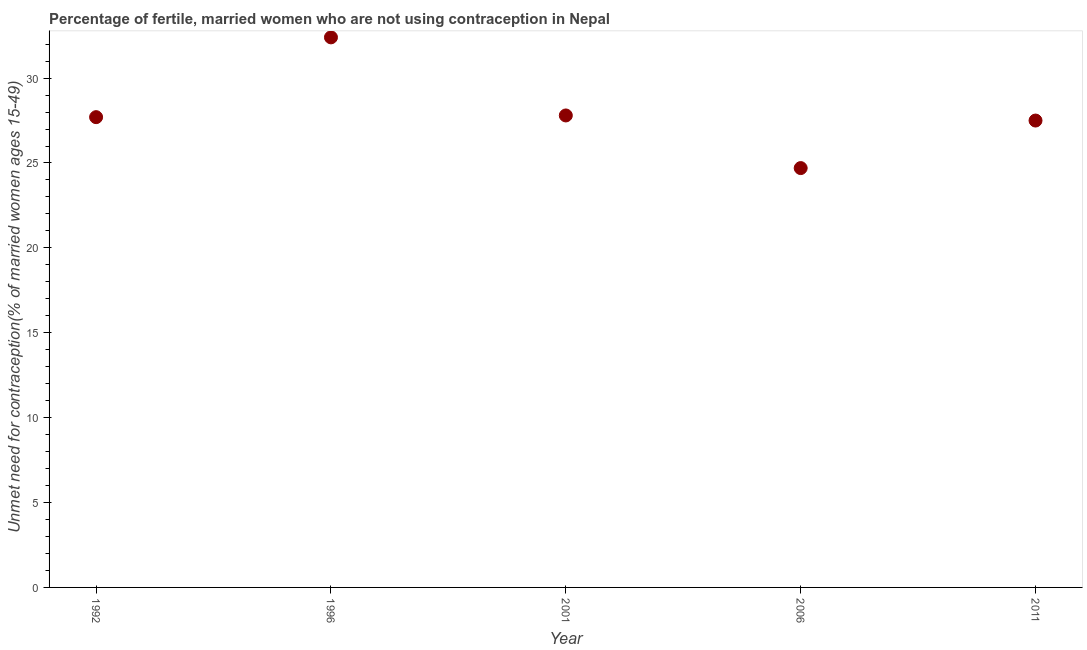What is the number of married women who are not using contraception in 1996?
Your answer should be very brief. 32.4. Across all years, what is the maximum number of married women who are not using contraception?
Offer a terse response. 32.4. Across all years, what is the minimum number of married women who are not using contraception?
Make the answer very short. 24.7. In which year was the number of married women who are not using contraception maximum?
Your answer should be compact. 1996. What is the sum of the number of married women who are not using contraception?
Keep it short and to the point. 140.1. What is the difference between the number of married women who are not using contraception in 2006 and 2011?
Give a very brief answer. -2.8. What is the average number of married women who are not using contraception per year?
Give a very brief answer. 28.02. What is the median number of married women who are not using contraception?
Your answer should be very brief. 27.7. Do a majority of the years between 2001 and 1992 (inclusive) have number of married women who are not using contraception greater than 15 %?
Make the answer very short. No. What is the ratio of the number of married women who are not using contraception in 2001 to that in 2011?
Give a very brief answer. 1.01. Is the number of married women who are not using contraception in 2001 less than that in 2011?
Make the answer very short. No. What is the difference between the highest and the second highest number of married women who are not using contraception?
Your answer should be compact. 4.6. Is the sum of the number of married women who are not using contraception in 1992 and 2006 greater than the maximum number of married women who are not using contraception across all years?
Give a very brief answer. Yes. What is the difference between the highest and the lowest number of married women who are not using contraception?
Make the answer very short. 7.7. In how many years, is the number of married women who are not using contraception greater than the average number of married women who are not using contraception taken over all years?
Your response must be concise. 1. How many dotlines are there?
Provide a short and direct response. 1. What is the difference between two consecutive major ticks on the Y-axis?
Offer a terse response. 5. Are the values on the major ticks of Y-axis written in scientific E-notation?
Your answer should be compact. No. Does the graph contain any zero values?
Make the answer very short. No. Does the graph contain grids?
Keep it short and to the point. No. What is the title of the graph?
Give a very brief answer. Percentage of fertile, married women who are not using contraception in Nepal. What is the label or title of the Y-axis?
Give a very brief answer.  Unmet need for contraception(% of married women ages 15-49). What is the  Unmet need for contraception(% of married women ages 15-49) in 1992?
Offer a very short reply. 27.7. What is the  Unmet need for contraception(% of married women ages 15-49) in 1996?
Make the answer very short. 32.4. What is the  Unmet need for contraception(% of married women ages 15-49) in 2001?
Provide a succinct answer. 27.8. What is the  Unmet need for contraception(% of married women ages 15-49) in 2006?
Give a very brief answer. 24.7. What is the  Unmet need for contraception(% of married women ages 15-49) in 2011?
Provide a short and direct response. 27.5. What is the difference between the  Unmet need for contraception(% of married women ages 15-49) in 1992 and 1996?
Ensure brevity in your answer.  -4.7. What is the difference between the  Unmet need for contraception(% of married women ages 15-49) in 1992 and 2011?
Your answer should be very brief. 0.2. What is the difference between the  Unmet need for contraception(% of married women ages 15-49) in 1996 and 2006?
Ensure brevity in your answer.  7.7. What is the difference between the  Unmet need for contraception(% of married women ages 15-49) in 1996 and 2011?
Ensure brevity in your answer.  4.9. What is the difference between the  Unmet need for contraception(% of married women ages 15-49) in 2001 and 2006?
Ensure brevity in your answer.  3.1. What is the ratio of the  Unmet need for contraception(% of married women ages 15-49) in 1992 to that in 1996?
Your answer should be very brief. 0.85. What is the ratio of the  Unmet need for contraception(% of married women ages 15-49) in 1992 to that in 2001?
Your answer should be very brief. 1. What is the ratio of the  Unmet need for contraception(% of married women ages 15-49) in 1992 to that in 2006?
Offer a terse response. 1.12. What is the ratio of the  Unmet need for contraception(% of married women ages 15-49) in 1996 to that in 2001?
Offer a very short reply. 1.17. What is the ratio of the  Unmet need for contraception(% of married women ages 15-49) in 1996 to that in 2006?
Offer a terse response. 1.31. What is the ratio of the  Unmet need for contraception(% of married women ages 15-49) in 1996 to that in 2011?
Provide a succinct answer. 1.18. What is the ratio of the  Unmet need for contraception(% of married women ages 15-49) in 2001 to that in 2006?
Your answer should be very brief. 1.13. What is the ratio of the  Unmet need for contraception(% of married women ages 15-49) in 2006 to that in 2011?
Keep it short and to the point. 0.9. 